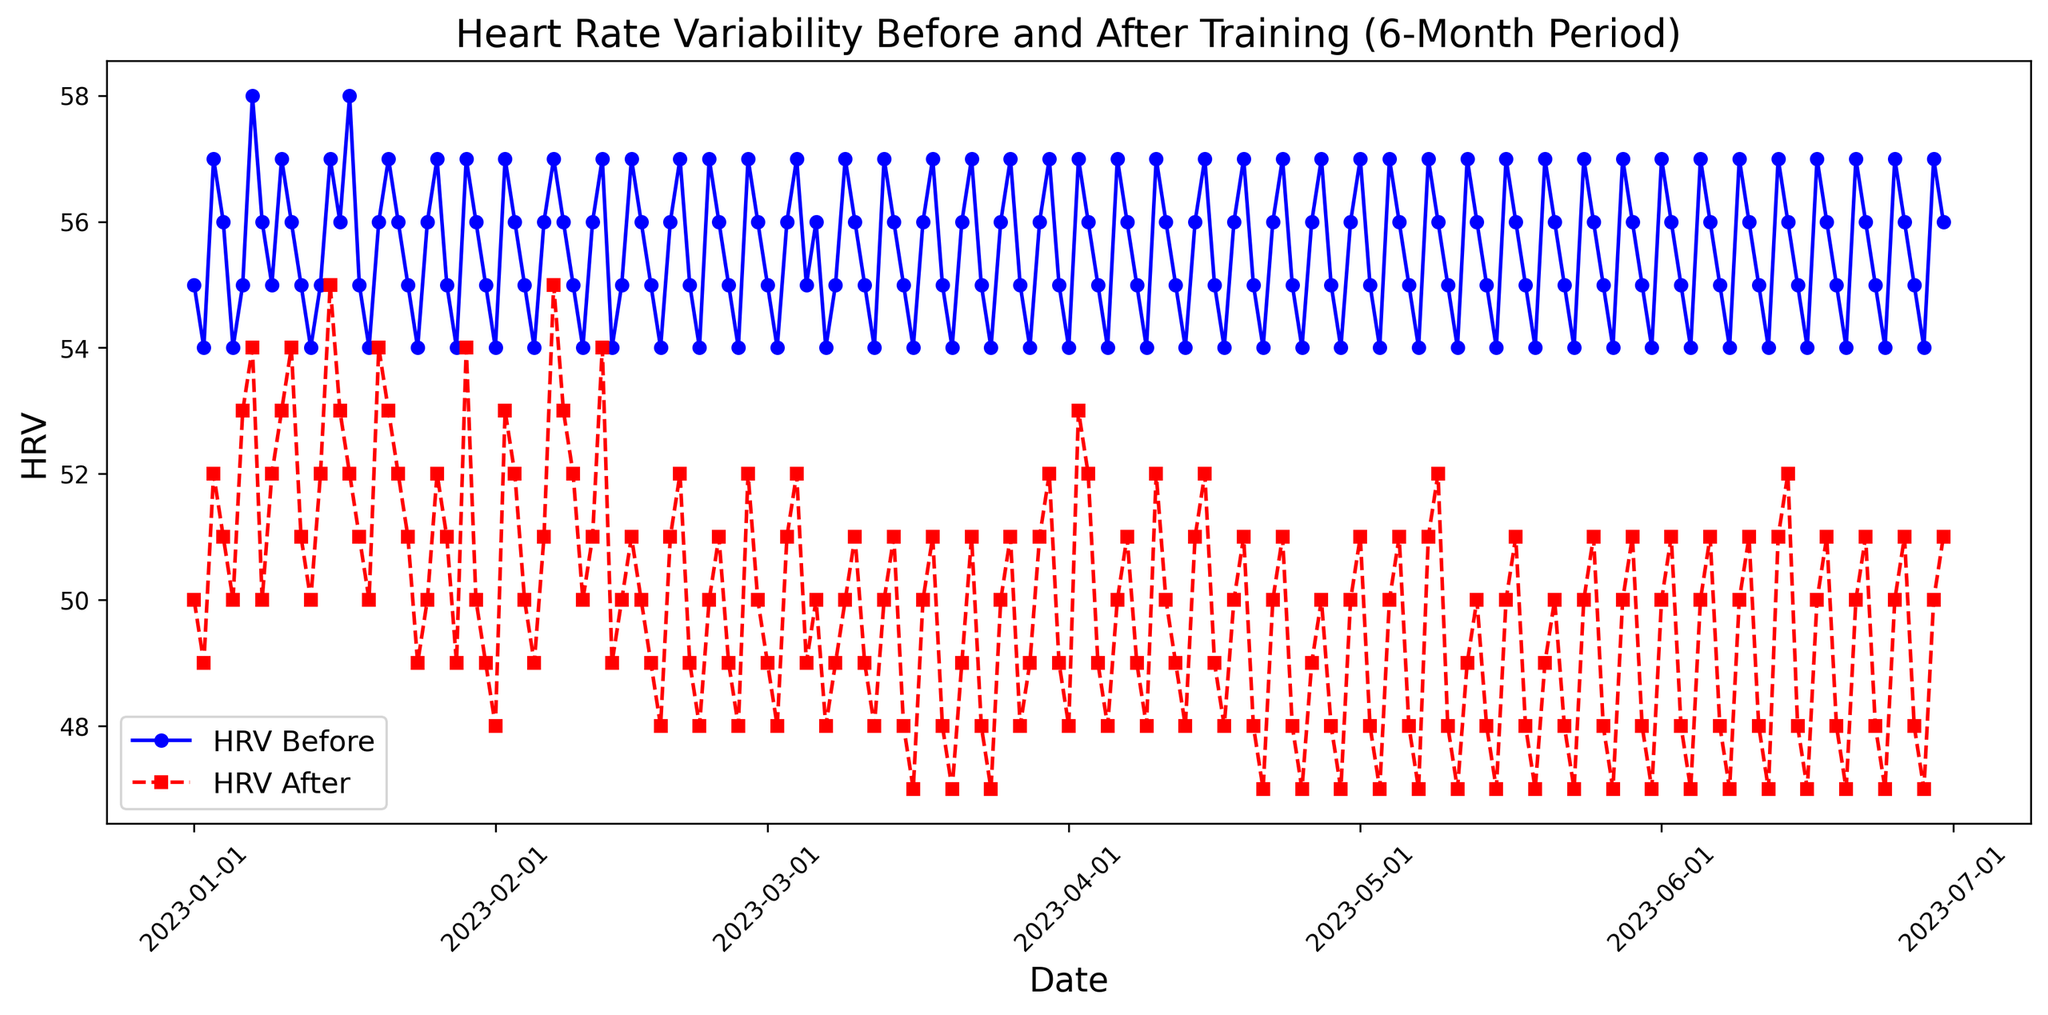what is the difference in HRV before and after training on June 30, 2023? Locate the values for June 30, 2023. The HRV before training is 56, and the HRV after training is 51. Subtract HRV after from HRV before (56 - 51)
Answer: 5 what is the average HRV before training in January 2023? Calculate the average of the HRV before values for all days in January 2023. Those values are [55, 54, 57, 56, 54, 55, 58, 56, 55, 57, 56, 55, 54, 55, 57, 56, 58, 55, 54, 56, 57, 56, 55, 54, 56, 57, 55, 54, 57, 56, 55]. Summing these gives 1729. Divide by the number of days (31)
Answer: 55.77 on which date is the largest HRV drop observed from before to after training? Examine the data for the largest difference between HRV before and after training. The largest drop is observed on January 1, 2023, where the HRV before is 55 and after is 50, resulting in a drop of 5
Answer: January 1, 2023 what is the trend of HRV before and after training over the 6-month period? By visually examining the lines in the plot, observe the general direction of the HRV before and after training. Both lines show a slight decreasing trend over the 6-month period
Answer: Slight decreasing is the HRV before training generally higher or lower than HRV after training? Visually compare the blue line representing HRV before training with the red line representing HRV after training. The blue line is consistently above the red line, indicating that HRV before training is generally higher
Answer: Higher what is the average HRV after training in February 2023? Calculate the average of the HRV after values for all days in February 2023. Those values are [48, 48, 48, 49, 50, 51, 49, 48, 50, 51, 52, 51, 52, 50, 52, 53, 50, 49, 50, 50, 49, 48, 49, 50, 51, 50, 51, 50]. Summing these gives 1361. Divide by the number of days (28)
Answer: 48.61 